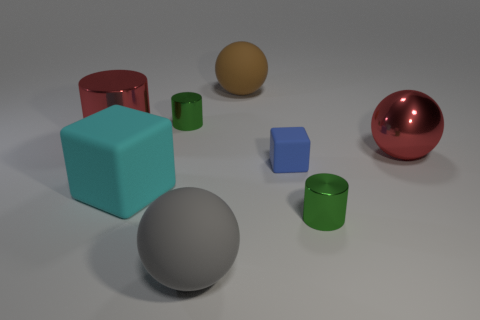What number of small blocks have the same material as the gray object?
Provide a short and direct response. 1. What number of things are big red cylinders or yellow metal cubes?
Make the answer very short. 1. Is there a large gray matte sphere?
Give a very brief answer. Yes. What is the material of the green object that is behind the small metallic cylinder in front of the rubber cube that is on the left side of the tiny matte cube?
Give a very brief answer. Metal. Are there fewer blue matte blocks on the left side of the big red metallic cylinder than big cyan objects?
Ensure brevity in your answer.  Yes. What is the material of the block that is the same size as the red shiny cylinder?
Keep it short and to the point. Rubber. What is the size of the thing that is both to the right of the tiny rubber object and in front of the blue rubber cube?
Your response must be concise. Small. What size is the gray thing that is the same shape as the big brown thing?
Keep it short and to the point. Large. How many things are either red shiny spheres or red metallic things that are right of the big brown matte ball?
Offer a terse response. 1. The gray rubber object has what shape?
Make the answer very short. Sphere. 